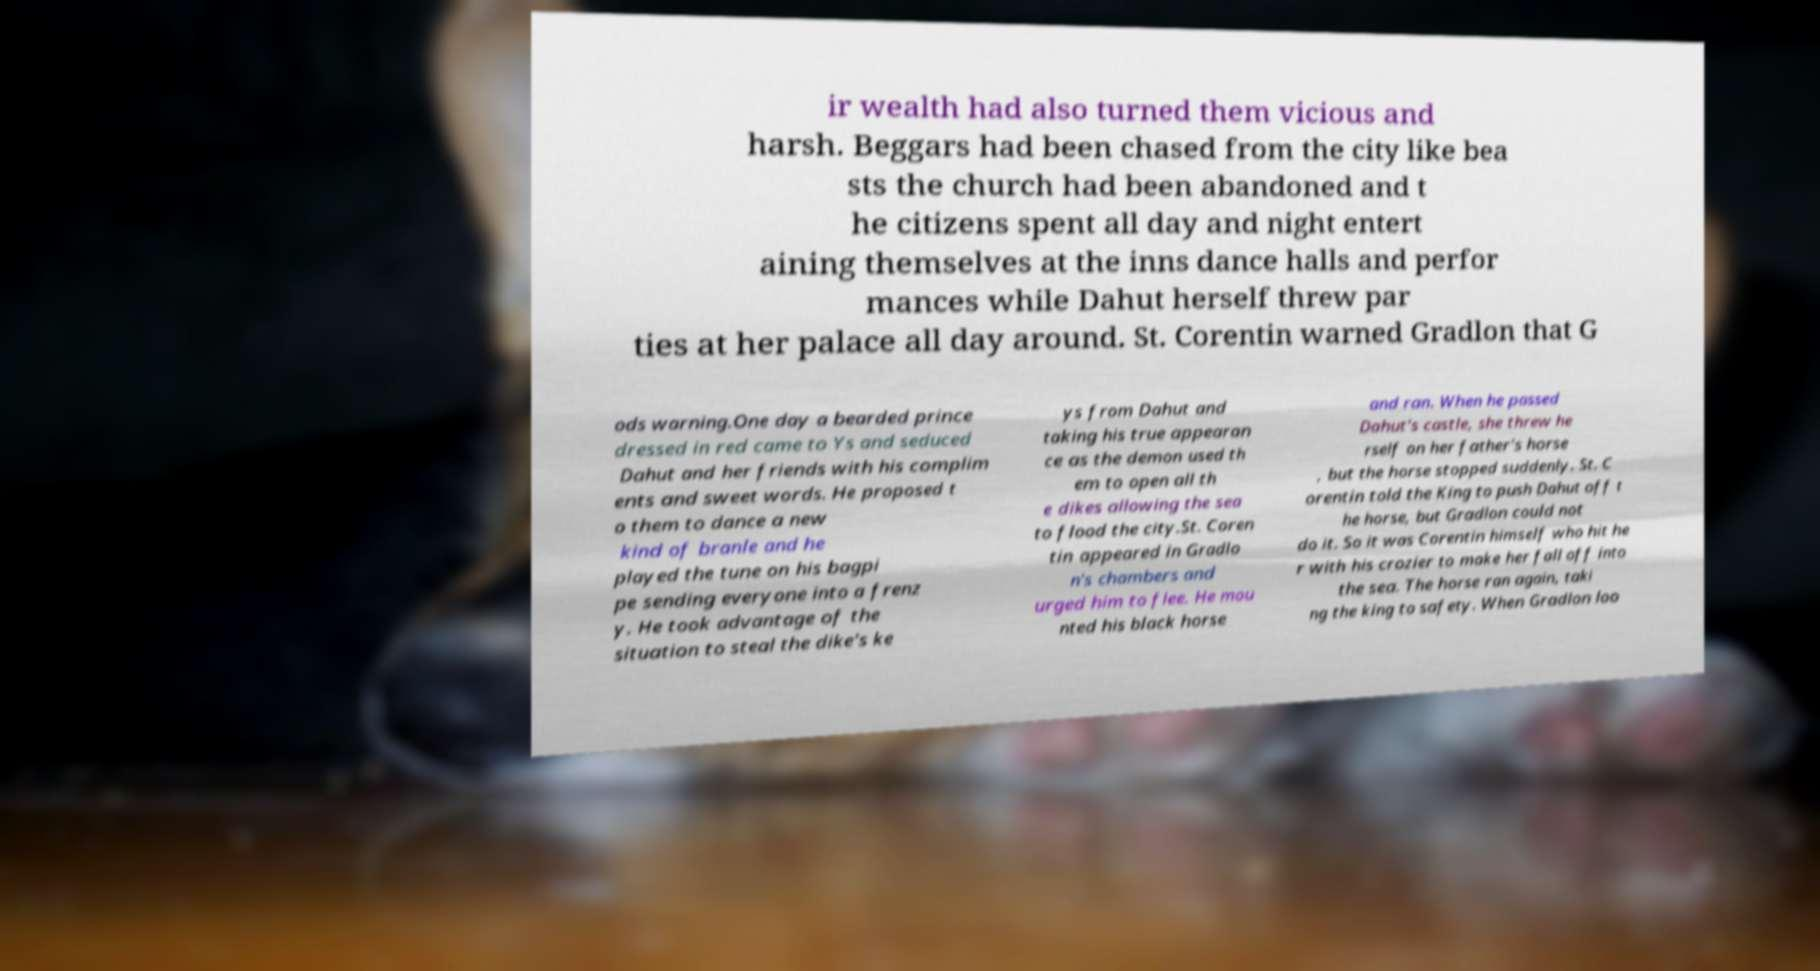Can you accurately transcribe the text from the provided image for me? ir wealth had also turned them vicious and harsh. Beggars had been chased from the city like bea sts the church had been abandoned and t he citizens spent all day and night entert aining themselves at the inns dance halls and perfor mances while Dahut herself threw par ties at her palace all day around. St. Corentin warned Gradlon that G ods warning.One day a bearded prince dressed in red came to Ys and seduced Dahut and her friends with his complim ents and sweet words. He proposed t o them to dance a new kind of branle and he played the tune on his bagpi pe sending everyone into a frenz y. He took advantage of the situation to steal the dike's ke ys from Dahut and taking his true appearan ce as the demon used th em to open all th e dikes allowing the sea to flood the city.St. Coren tin appeared in Gradlo n's chambers and urged him to flee. He mou nted his black horse and ran. When he passed Dahut's castle, she threw he rself on her father's horse , but the horse stopped suddenly. St. C orentin told the King to push Dahut off t he horse, but Gradlon could not do it. So it was Corentin himself who hit he r with his crozier to make her fall off into the sea. The horse ran again, taki ng the king to safety. When Gradlon loo 